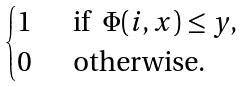<formula> <loc_0><loc_0><loc_500><loc_500>\begin{cases} 1 & \text { \ if \ } { \Phi } ( i , x ) \leq y , \\ 0 & \text { \ otherwise} . \end{cases}</formula> 